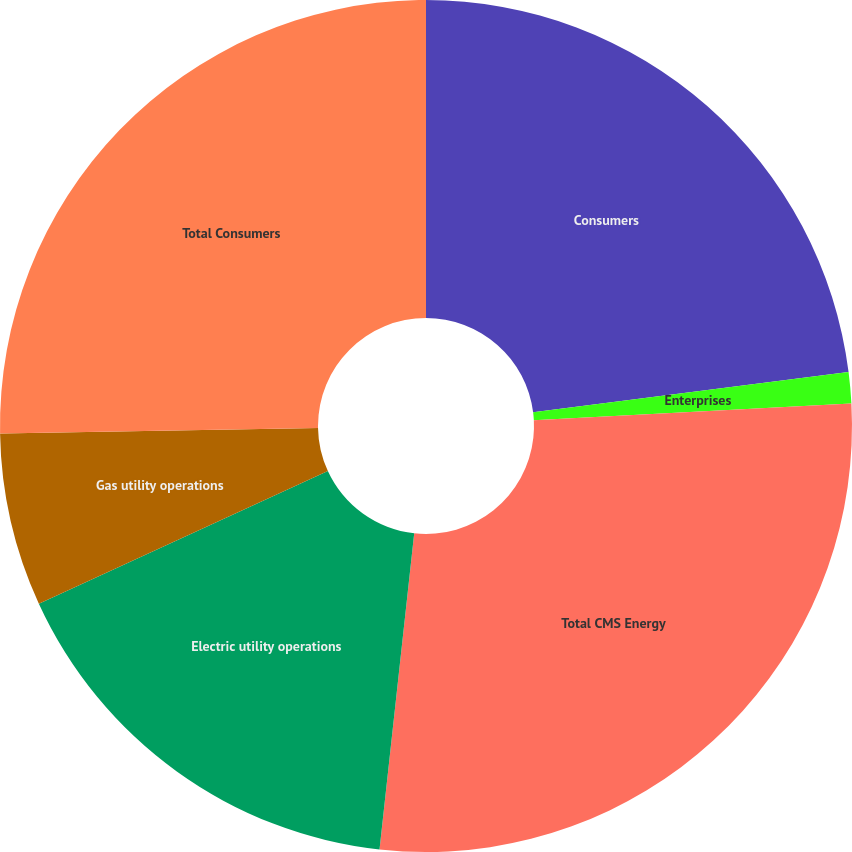<chart> <loc_0><loc_0><loc_500><loc_500><pie_chart><fcel>Consumers<fcel>Enterprises<fcel>Total CMS Energy<fcel>Electric utility operations<fcel>Gas utility operations<fcel>Total Consumers<nl><fcel>22.98%<fcel>1.18%<fcel>27.58%<fcel>16.41%<fcel>6.57%<fcel>25.28%<nl></chart> 